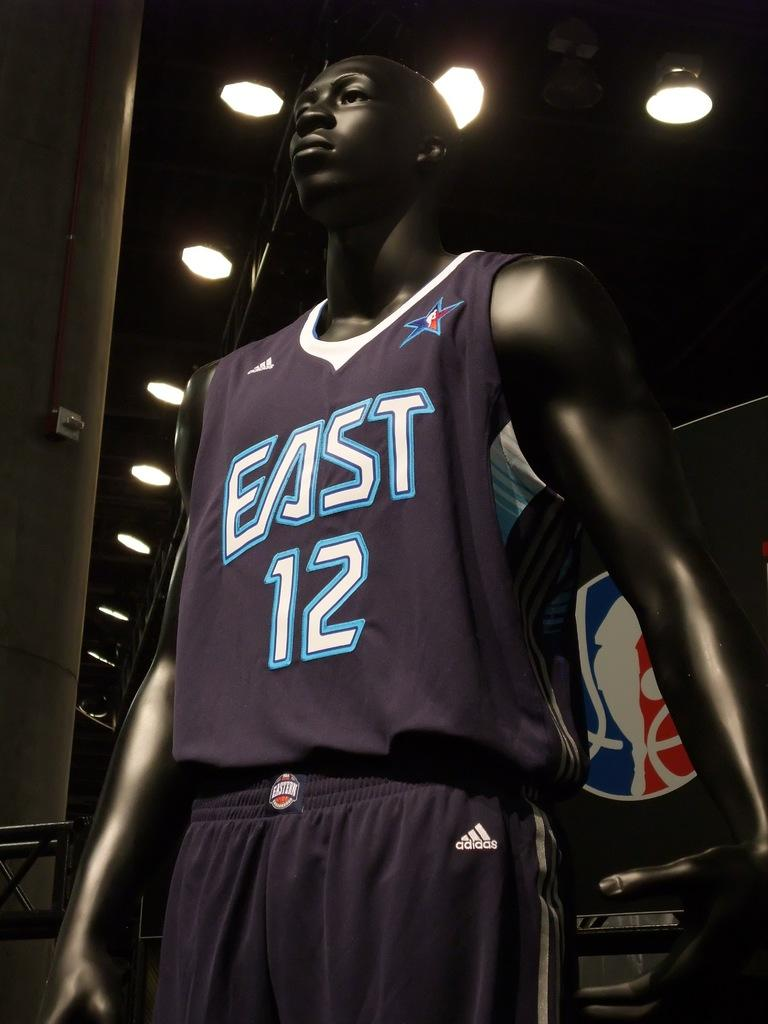<image>
Present a compact description of the photo's key features. A mannequin models athletic clothing labelled for a team called East. 